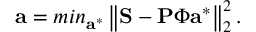<formula> <loc_0><loc_0><loc_500><loc_500>a = \min _ { a ^ { * } } \left \| S - P \Phi a ^ { * } \right \| _ { 2 } ^ { 2 } .</formula> 